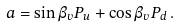Convert formula to latex. <formula><loc_0><loc_0><loc_500><loc_500>a = \sin \beta _ { v } P _ { u } + \cos \beta _ { v } P _ { d } \, .</formula> 